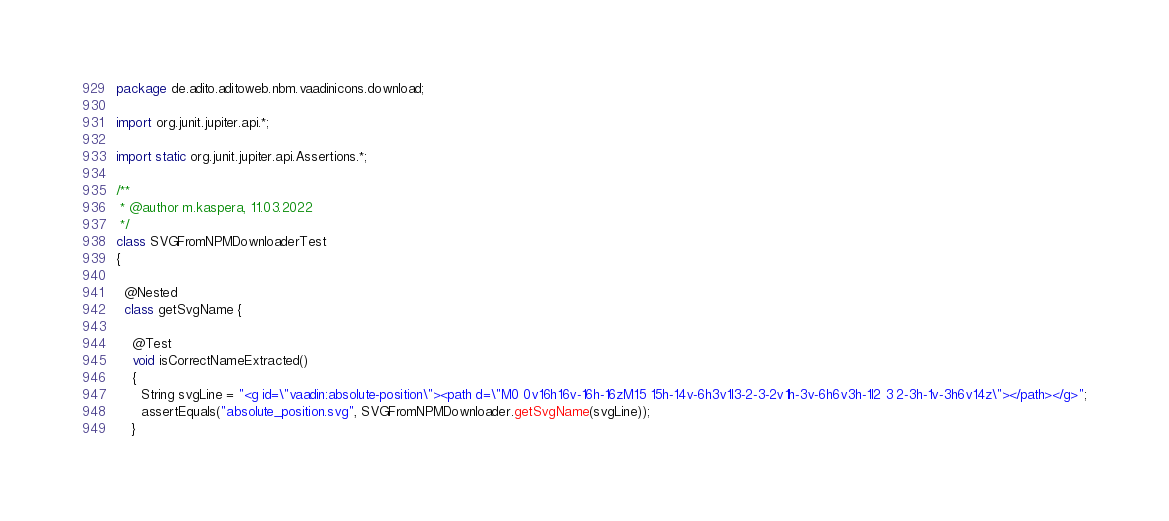<code> <loc_0><loc_0><loc_500><loc_500><_Java_>package de.adito.aditoweb.nbm.vaadinicons.download;

import org.junit.jupiter.api.*;

import static org.junit.jupiter.api.Assertions.*;

/**
 * @author m.kaspera, 11.03.2022
 */
class SVGFromNPMDownloaderTest
{

  @Nested
  class getSvgName {

    @Test
    void isCorrectNameExtracted()
    {
      String svgLine = "<g id=\"vaadin:absolute-position\"><path d=\"M0 0v16h16v-16h-16zM15 15h-14v-6h3v1l3-2-3-2v1h-3v-6h6v3h-1l2 3 2-3h-1v-3h6v14z\"></path></g>";
      assertEquals("absolute_position.svg", SVGFromNPMDownloader.getSvgName(svgLine));
    }
</code> 